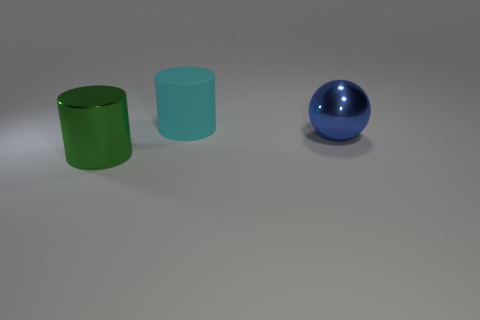Add 3 yellow cylinders. How many objects exist? 6 Subtract all balls. How many objects are left? 2 Subtract all small blue metal cylinders. Subtract all metallic objects. How many objects are left? 1 Add 1 green metallic cylinders. How many green metallic cylinders are left? 2 Add 1 blue metallic balls. How many blue metallic balls exist? 2 Subtract 0 cyan spheres. How many objects are left? 3 